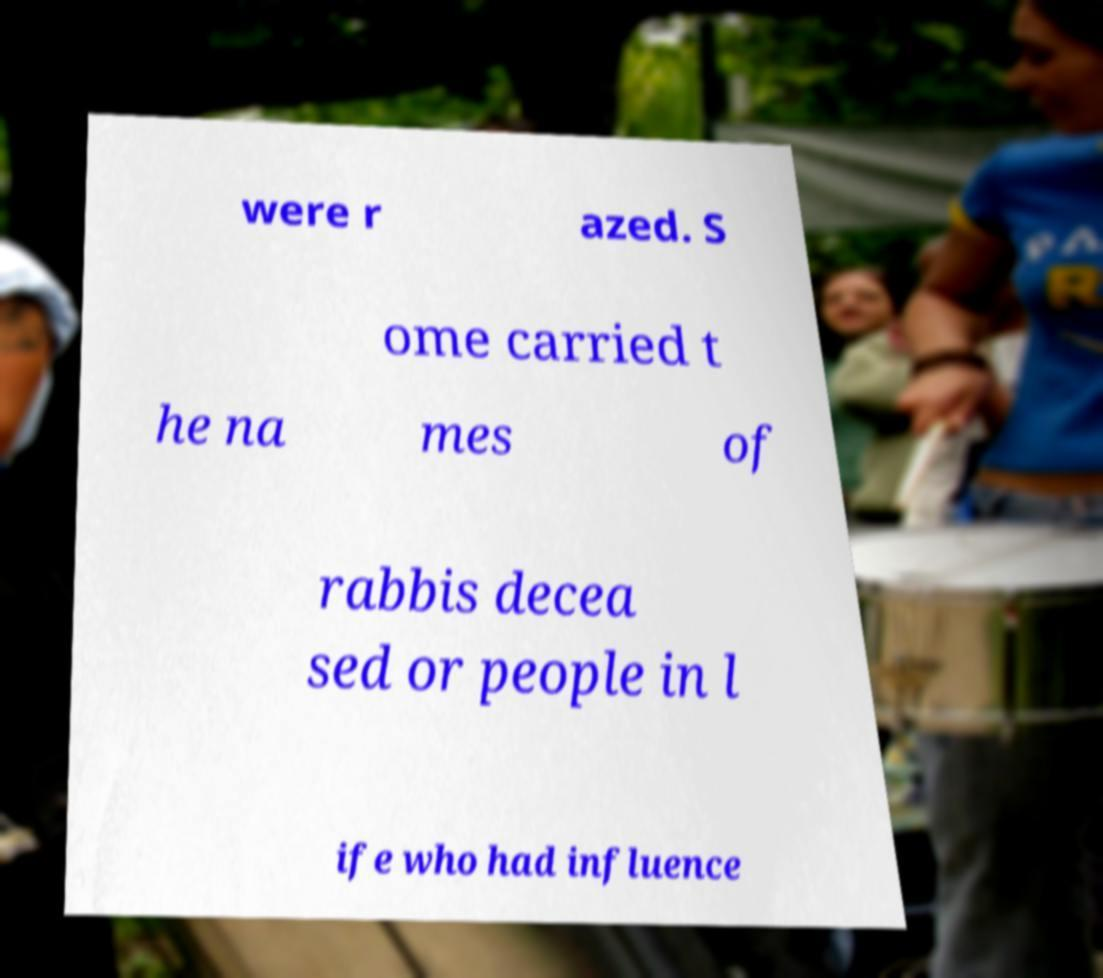What messages or text are displayed in this image? I need them in a readable, typed format. were r azed. S ome carried t he na mes of rabbis decea sed or people in l ife who had influence 